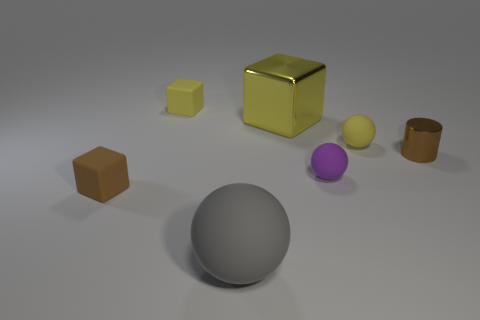What number of small cubes are both in front of the tiny brown cylinder and behind the yellow matte ball?
Your answer should be compact. 0. Is the number of small brown metallic things that are in front of the large shiny thing less than the number of gray things?
Ensure brevity in your answer.  No. What is the shape of the brown shiny object that is the same size as the yellow sphere?
Your answer should be compact. Cylinder. What number of other objects are there of the same color as the large metallic thing?
Make the answer very short. 2. Is the gray object the same size as the yellow metal block?
Provide a succinct answer. Yes. What number of things are large cubes or metallic things on the left side of the small yellow sphere?
Offer a terse response. 1. Is the number of metallic cylinders that are behind the yellow metal cube less than the number of objects that are on the left side of the brown shiny cylinder?
Give a very brief answer. Yes. How many other things are there of the same material as the yellow ball?
Provide a short and direct response. 4. Do the tiny block to the right of the brown rubber object and the big block have the same color?
Provide a short and direct response. Yes. Is there a brown metallic thing that is in front of the tiny brown object that is to the right of the yellow ball?
Your answer should be compact. No. 